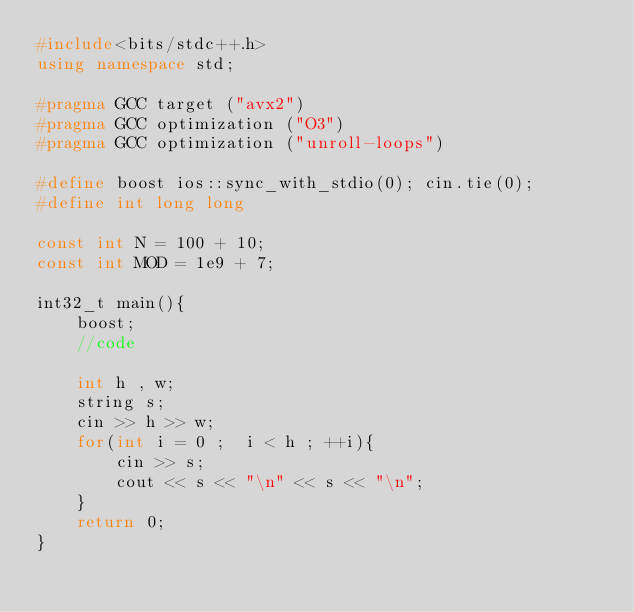<code> <loc_0><loc_0><loc_500><loc_500><_C++_>#include<bits/stdc++.h>
using namespace std;

#pragma GCC target ("avx2")
#pragma GCC optimization ("O3")
#pragma GCC optimization ("unroll-loops")

#define boost ios::sync_with_stdio(0); cin.tie(0);
#define int long long

const int N = 100 + 10;
const int MOD = 1e9 + 7;

int32_t main(){
    boost;
    //code
 	
 	int h , w;
 	string s;
 	cin >> h >> w;
 	for(int i = 0 ;  i < h ; ++i){
 		cin >> s;
 		cout << s << "\n" << s << "\n";
 	}   
    return 0;
}</code> 